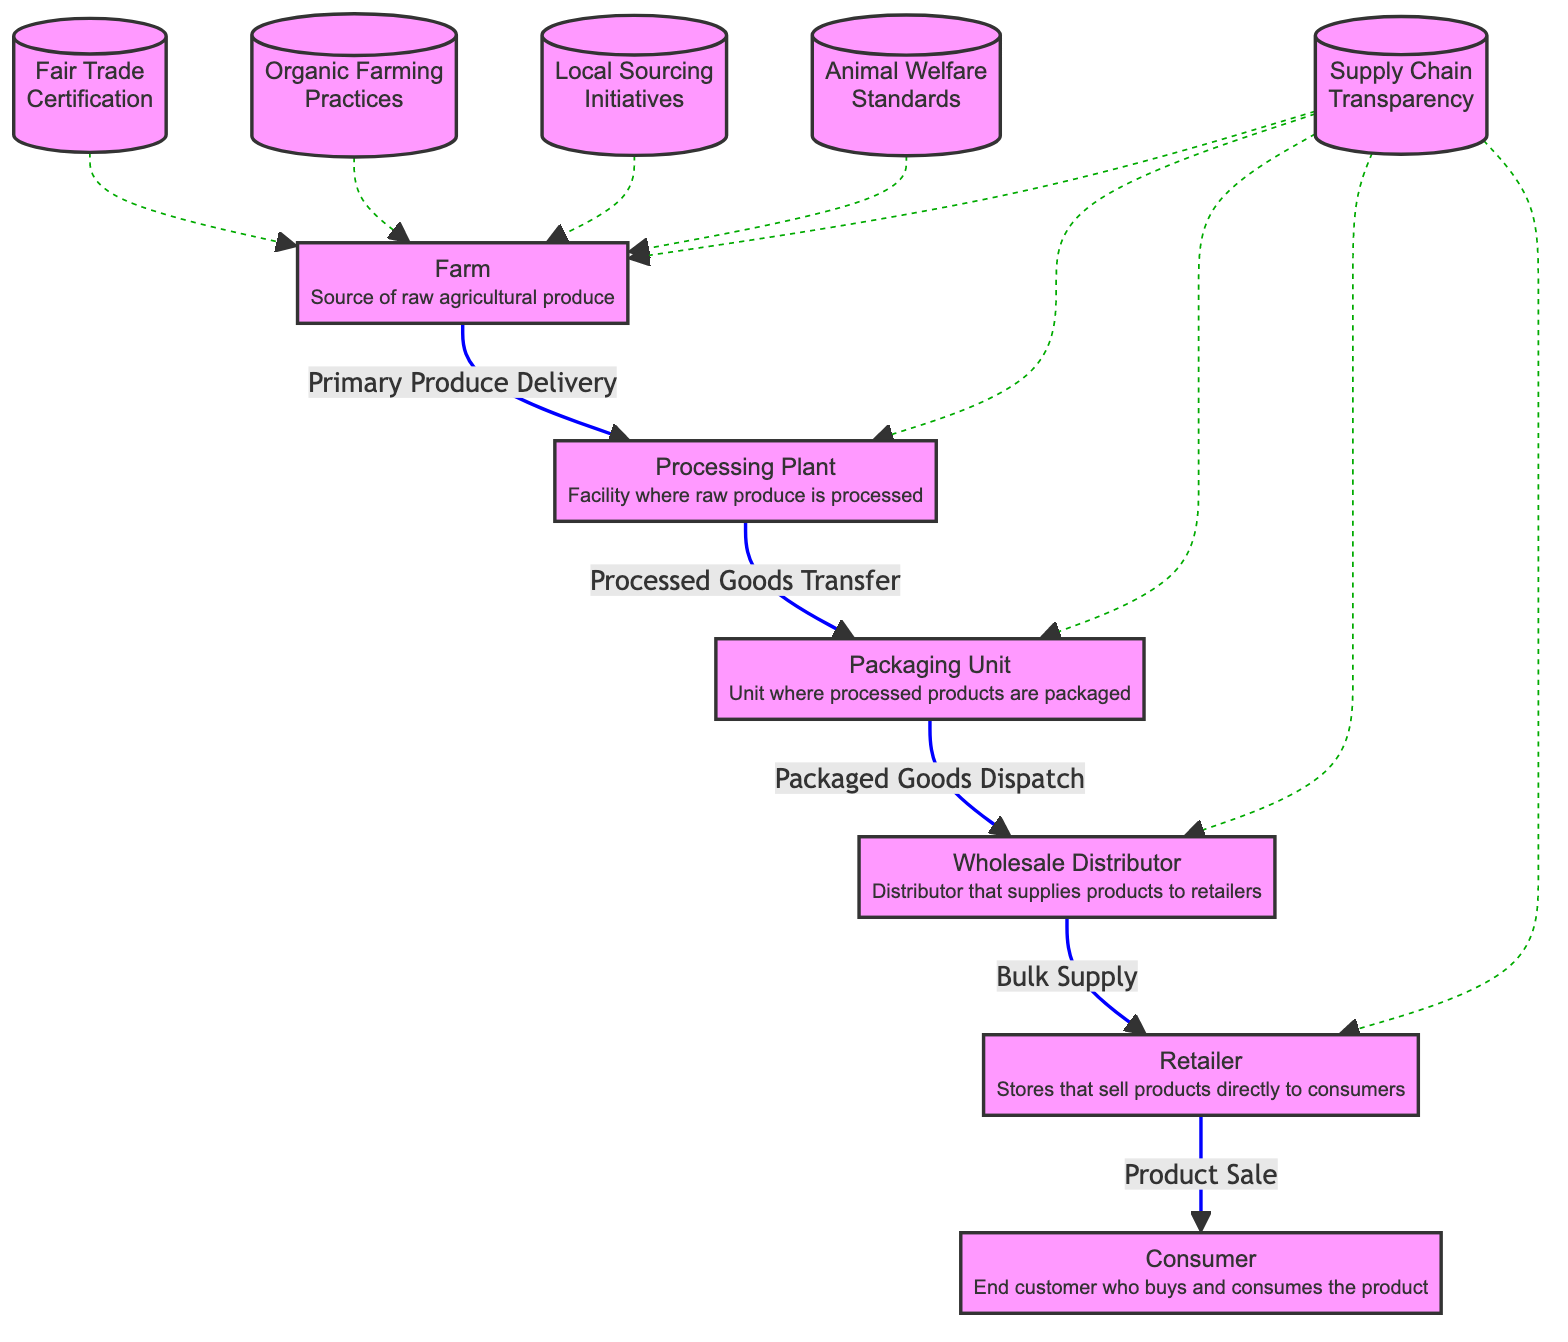What is the first node in the food chain? The diagram shows "Farm" as the starting point, indicating it is the first node in the food supply chain.
Answer: Farm How many links are there from the 'Packaging Unit' to other nodes? The 'Packaging Unit' has one outgoing link, which goes to the 'Wholesale Distributor', as depicted in the diagram.
Answer: 1 Which practice is linked to the 'Farm' node? The 'Fair Trade', 'Organic Farming', 'Local Sourcing', 'Animal Welfare', and 'Transparency' practices are all connected to the 'Farm' node in the diagram.
Answer: Fair Trade, Organic Farming, Local Sourcing, Animal Welfare, Transparency What type of certification is associated with ethical sourcing? The 'Fair Trade Certification' associates ethical sourcing with the 'Farm' node in the diagram.
Answer: Fair Trade From which node does the 'Consumer' directly receive the product? The 'Consumer' receives the product directly from the 'Retailer' as indicated by the direct link in the diagram.
Answer: Retailer What color represents the primary delivery flow in the diagram? The primary delivery flow is represented by blue, as shown by the link styles in the diagram.
Answer: Blue Which node has the most connections? The 'Farm' node has multiple connections to different practices, indicating it interacts with several ethical sourcing initiatives shown in the diagram.
Answer: Farm What is the main function of the 'Processing Plant' node? The 'Processing Plant' is responsible for processing raw agricultural produce into processed goods before transferring them to the next stage.
Answer: Processed Goods Transfer How does 'Transparency' impact the nodes in the diagram? 'Transparency' affects multiple nodes, including 'Farm', 'Processing Plant', 'Packaging Unit', 'Wholesale Distributor', and 'Retailer', signifying its role throughout the supply chain.
Answer: Multiple Nodes 